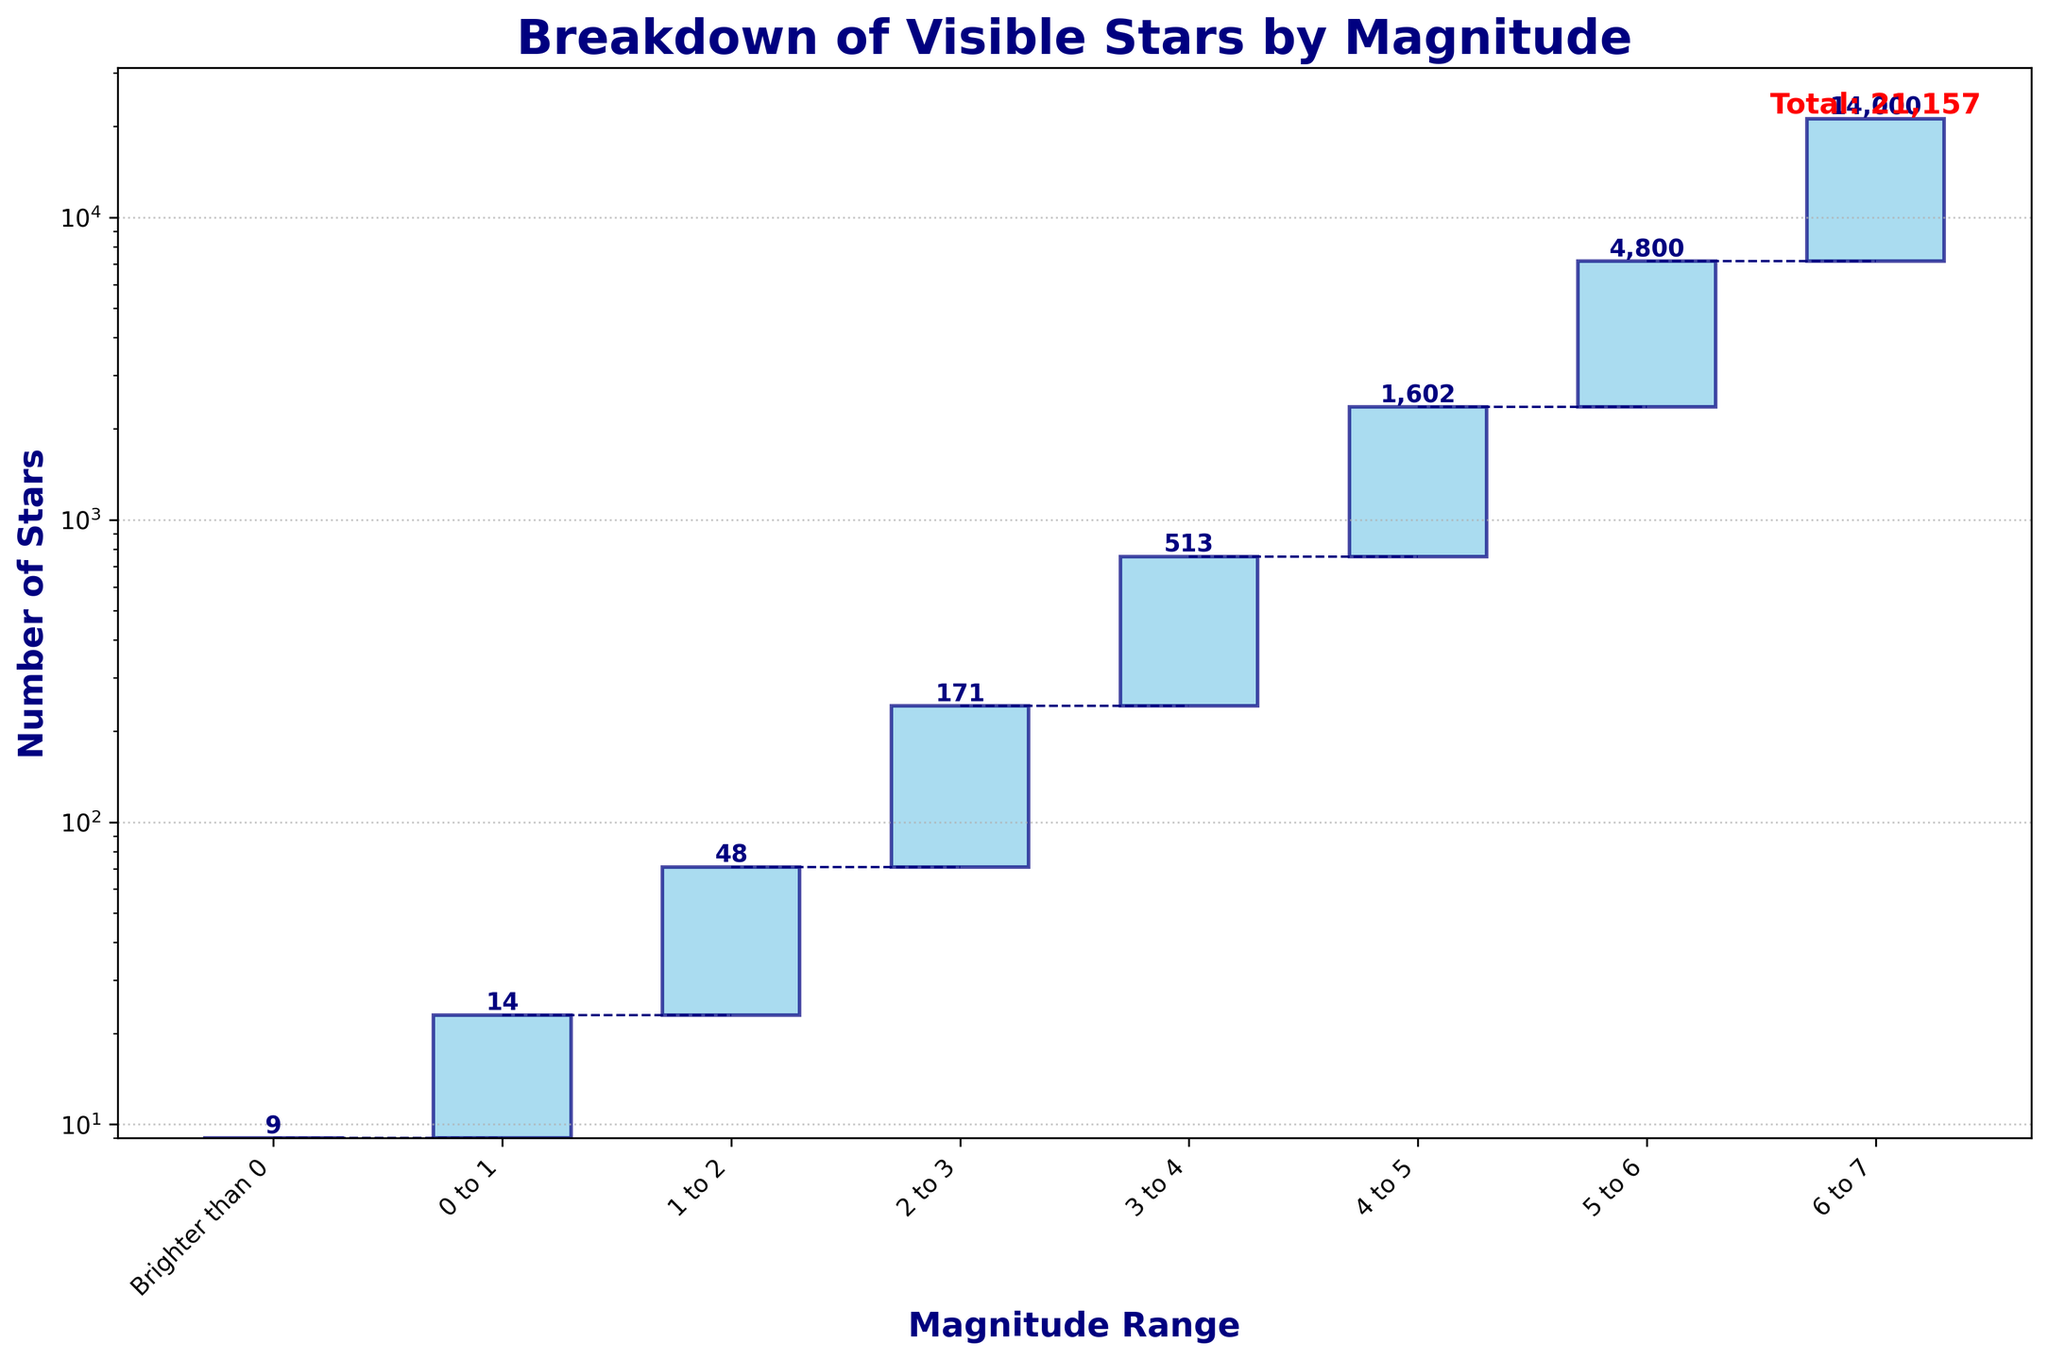What's the title of the chart? The chart's title is often located at the top center of the figure and summarizes the main topic of the chart.
Answer: Breakdown of Visible Stars by Magnitude What is the y-axis showing? The y-axis is labeled to show what is being measured. It often includes a numerical scale indicating the range of values presented.
Answer: Number of Stars How many stars are in the category from 4 to 5 magnitude? Look for the bar labeled '4 to 5' on the x-axis and read the value directly above or near it.
Answer: 1602 How many stars are visible that are brighter than 0 magnitude? Look for the bar labeled 'Brighter than 0' on the x-axis and check the value indicated.
Answer: 9 What is the total number of visible stars according to the figure? The total number of stars is often indicated somewhere on the figure, usually as a summary at the end or top.
Answer: 21,157 Which magnitude range has the highest number of visible stars? Compare the heights of the bars or the values indicated above each bar.
Answer: 6 to 7 How does the number of stars in the "5 to 6" range compare to the "3 to 4" range? Find both range bars and compare their heights or values directly to determine which is higher and by how much.
Answer: The "5 to 6" range has more stars (4800 vs. 513) What percentage of the total stars are in the "4 to 5" magnitude range? Divide the number of stars in the "4 to 5" range by the total number of stars and multiply by 100. \( \frac{1602}{21157} \times 100 = 7.57 \% \)
Answer: 7.57% How many stars are there between magnitude 3 and 5? Add the number of stars in the "3 to 4" and "4 to 5" categories. \( 513 + 1602 = 2115 \)
Answer: 2115 What magnitude range has the fewest visible stars? Compare the values of all the magnitude ranges to find the smallest one.
Answer: Brighter than 0 